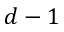<formula> <loc_0><loc_0><loc_500><loc_500>d - 1</formula> 